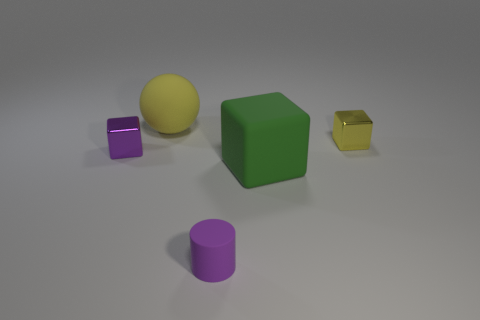Does the metal block that is to the left of the large cube have the same color as the small rubber cylinder?
Give a very brief answer. Yes. There is a small metal block to the left of the purple cylinder; does it have the same color as the small rubber object that is in front of the large green matte thing?
Give a very brief answer. Yes. There is a purple object that is behind the purple thing that is right of the small thing that is left of the big ball; what is its size?
Ensure brevity in your answer.  Small. The tiny thing that is both behind the small purple matte cylinder and on the right side of the tiny purple metallic object has what shape?
Provide a succinct answer. Cube. Are there an equal number of green matte things that are behind the big yellow matte sphere and yellow things behind the small yellow block?
Offer a terse response. No. Are there any cubes made of the same material as the big yellow ball?
Provide a short and direct response. Yes. Is the purple object that is in front of the green cube made of the same material as the big ball?
Your answer should be compact. Yes. There is a block that is behind the big rubber block and in front of the yellow metallic block; what is its size?
Offer a very short reply. Small. What color is the big matte sphere?
Offer a very short reply. Yellow. How many red metallic blocks are there?
Make the answer very short. 0. 